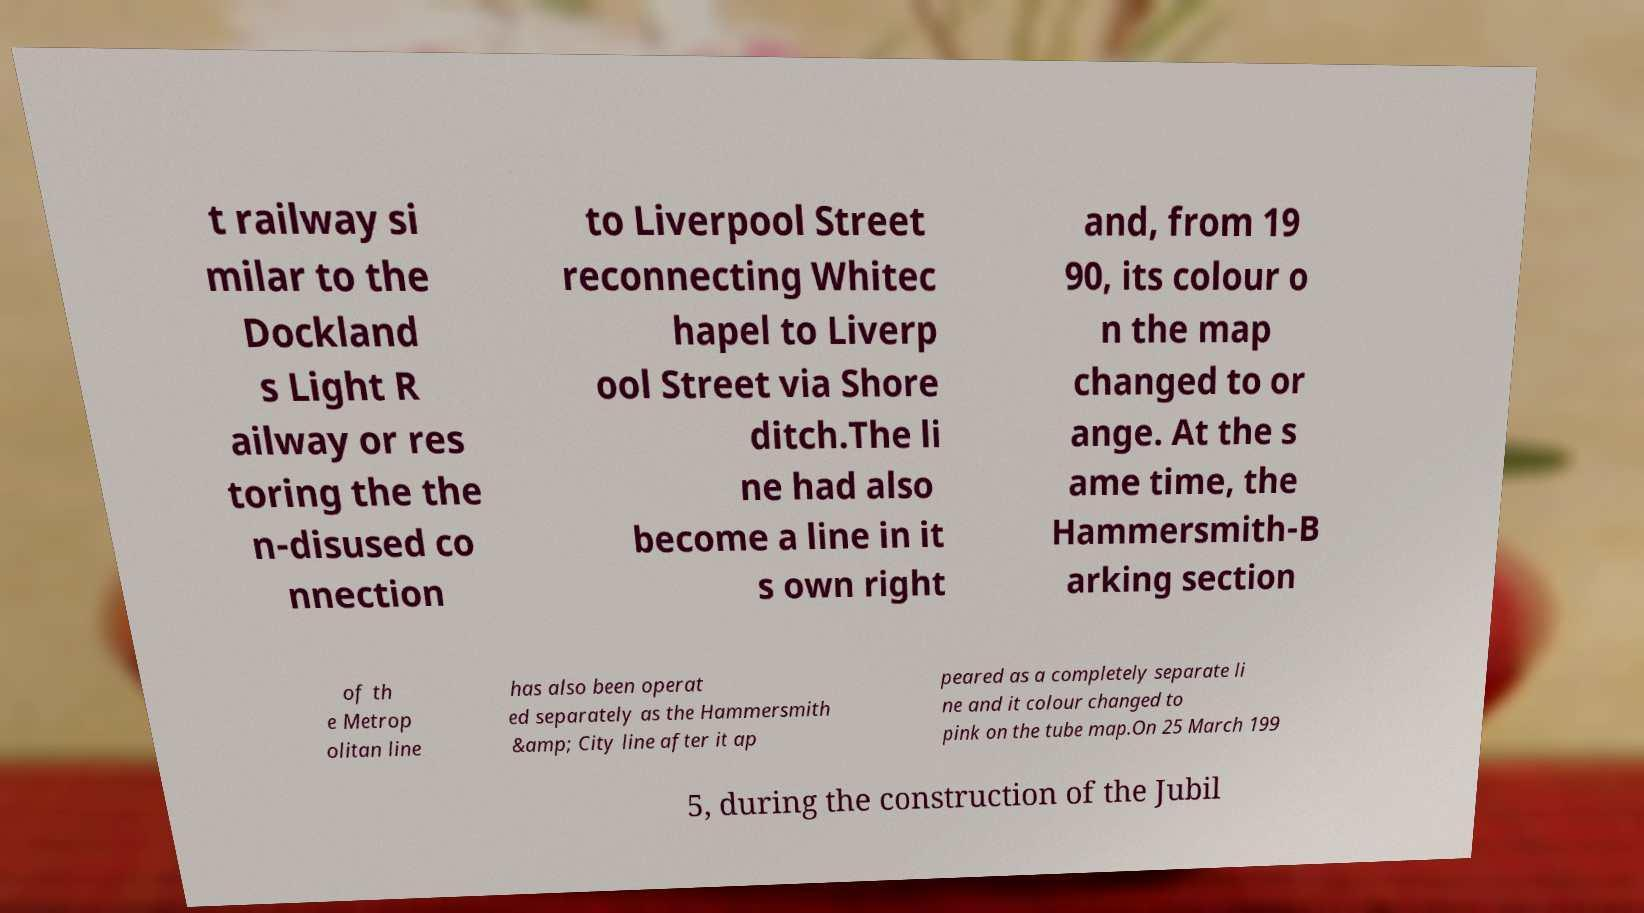Can you read and provide the text displayed in the image?This photo seems to have some interesting text. Can you extract and type it out for me? t railway si milar to the Dockland s Light R ailway or res toring the the n-disused co nnection to Liverpool Street reconnecting Whitec hapel to Liverp ool Street via Shore ditch.The li ne had also become a line in it s own right and, from 19 90, its colour o n the map changed to or ange. At the s ame time, the Hammersmith-B arking section of th e Metrop olitan line has also been operat ed separately as the Hammersmith &amp; City line after it ap peared as a completely separate li ne and it colour changed to pink on the tube map.On 25 March 199 5, during the construction of the Jubil 